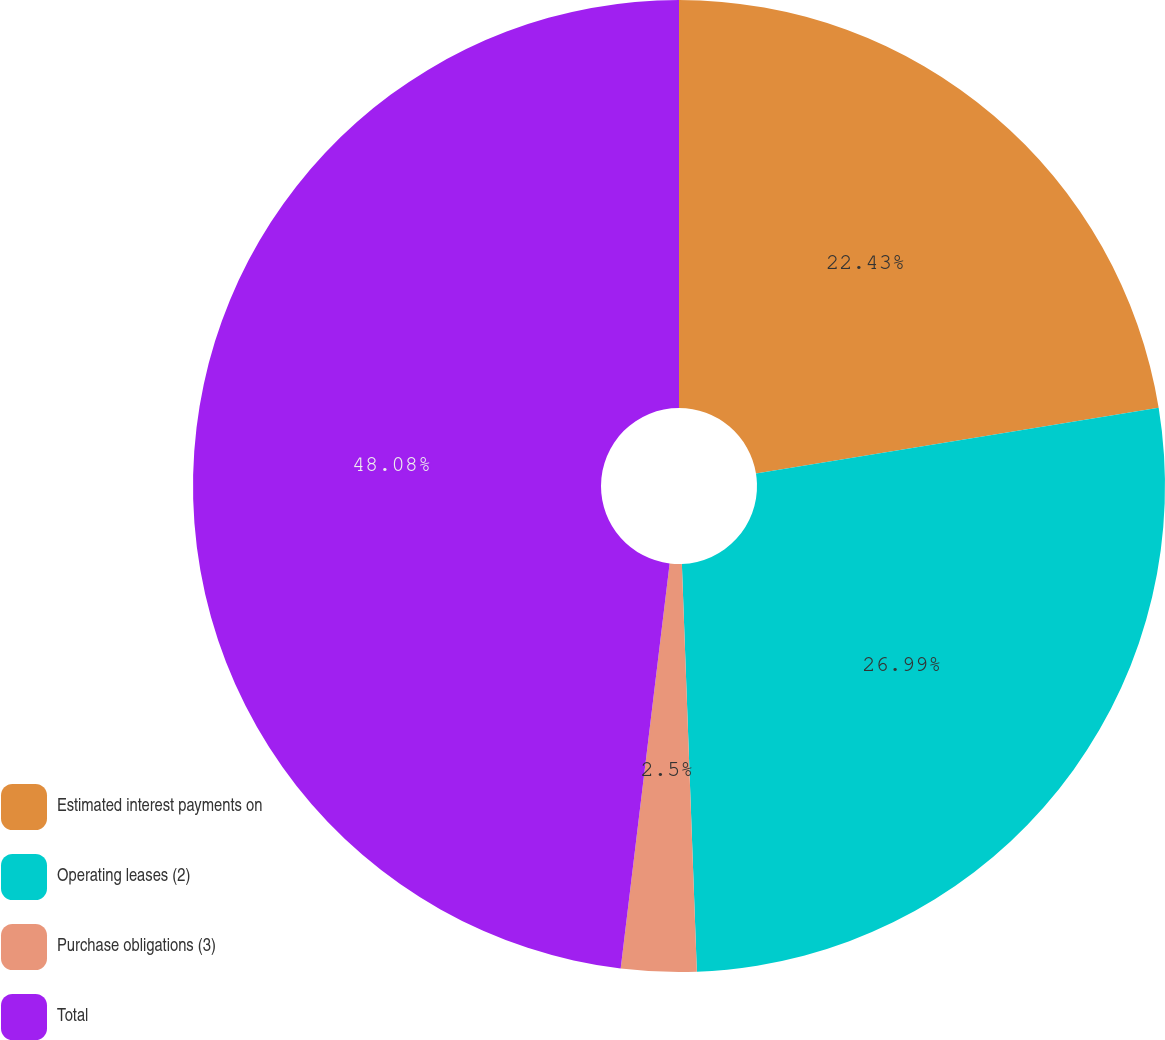Convert chart to OTSL. <chart><loc_0><loc_0><loc_500><loc_500><pie_chart><fcel>Estimated interest payments on<fcel>Operating leases (2)<fcel>Purchase obligations (3)<fcel>Total<nl><fcel>22.43%<fcel>26.99%<fcel>2.5%<fcel>48.09%<nl></chart> 